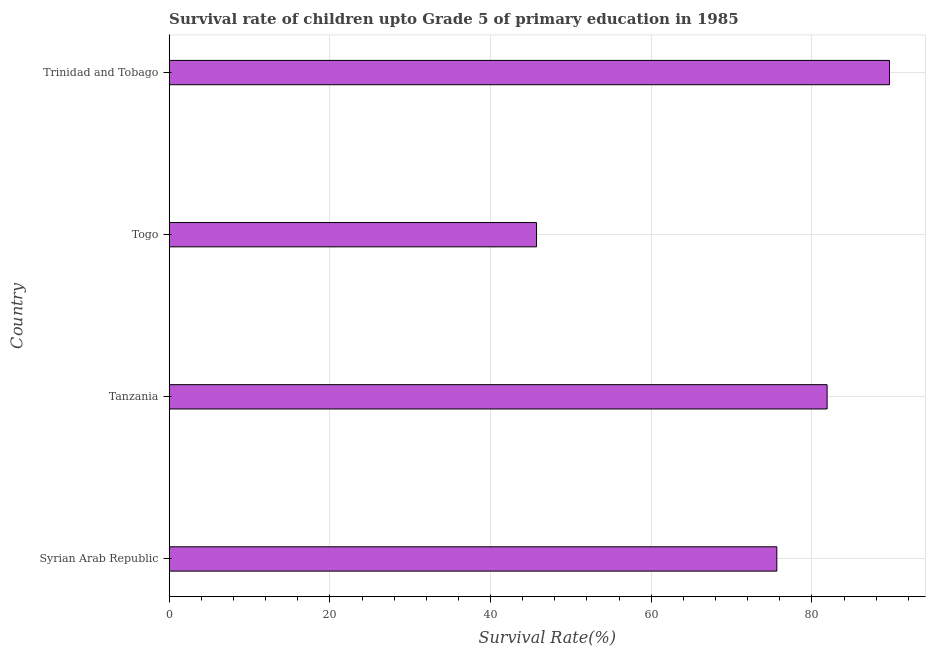Does the graph contain any zero values?
Make the answer very short. No. What is the title of the graph?
Ensure brevity in your answer.  Survival rate of children upto Grade 5 of primary education in 1985 . What is the label or title of the X-axis?
Offer a terse response. Survival Rate(%). What is the survival rate in Togo?
Provide a short and direct response. 45.72. Across all countries, what is the maximum survival rate?
Ensure brevity in your answer.  89.65. Across all countries, what is the minimum survival rate?
Make the answer very short. 45.72. In which country was the survival rate maximum?
Your answer should be very brief. Trinidad and Tobago. In which country was the survival rate minimum?
Make the answer very short. Togo. What is the sum of the survival rate?
Keep it short and to the point. 292.89. What is the difference between the survival rate in Syrian Arab Republic and Togo?
Give a very brief answer. 29.91. What is the average survival rate per country?
Ensure brevity in your answer.  73.22. What is the median survival rate?
Keep it short and to the point. 78.76. What is the ratio of the survival rate in Syrian Arab Republic to that in Togo?
Your answer should be very brief. 1.65. Is the survival rate in Syrian Arab Republic less than that in Togo?
Keep it short and to the point. No. Is the difference between the survival rate in Tanzania and Togo greater than the difference between any two countries?
Keep it short and to the point. No. What is the difference between the highest and the second highest survival rate?
Provide a succinct answer. 7.76. What is the difference between the highest and the lowest survival rate?
Keep it short and to the point. 43.93. In how many countries, is the survival rate greater than the average survival rate taken over all countries?
Your answer should be very brief. 3. How many bars are there?
Keep it short and to the point. 4. Are all the bars in the graph horizontal?
Make the answer very short. Yes. How many countries are there in the graph?
Keep it short and to the point. 4. What is the Survival Rate(%) of Syrian Arab Republic?
Offer a very short reply. 75.63. What is the Survival Rate(%) in Tanzania?
Offer a terse response. 81.89. What is the Survival Rate(%) of Togo?
Provide a short and direct response. 45.72. What is the Survival Rate(%) in Trinidad and Tobago?
Offer a very short reply. 89.65. What is the difference between the Survival Rate(%) in Syrian Arab Republic and Tanzania?
Give a very brief answer. -6.26. What is the difference between the Survival Rate(%) in Syrian Arab Republic and Togo?
Offer a very short reply. 29.91. What is the difference between the Survival Rate(%) in Syrian Arab Republic and Trinidad and Tobago?
Your answer should be compact. -14.02. What is the difference between the Survival Rate(%) in Tanzania and Togo?
Your answer should be very brief. 36.17. What is the difference between the Survival Rate(%) in Tanzania and Trinidad and Tobago?
Offer a terse response. -7.76. What is the difference between the Survival Rate(%) in Togo and Trinidad and Tobago?
Offer a very short reply. -43.93. What is the ratio of the Survival Rate(%) in Syrian Arab Republic to that in Tanzania?
Provide a succinct answer. 0.92. What is the ratio of the Survival Rate(%) in Syrian Arab Republic to that in Togo?
Provide a short and direct response. 1.65. What is the ratio of the Survival Rate(%) in Syrian Arab Republic to that in Trinidad and Tobago?
Your answer should be compact. 0.84. What is the ratio of the Survival Rate(%) in Tanzania to that in Togo?
Offer a terse response. 1.79. What is the ratio of the Survival Rate(%) in Togo to that in Trinidad and Tobago?
Your response must be concise. 0.51. 